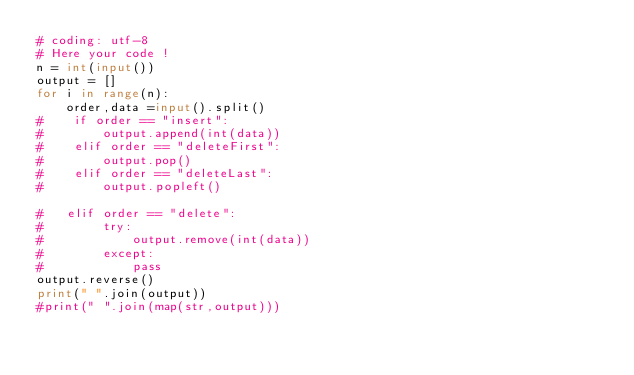<code> <loc_0><loc_0><loc_500><loc_500><_Python_># coding: utf-8
# Here your code !
n = int(input())
output = []
for i in range(n):
    order,data =input().split() 
#    if order == "insert":
#        output.append(int(data))
#    elif order == "deleteFirst":
#        output.pop()
#    elif order == "deleteLast":
#        output.popleft()

#   elif order == "delete":
#        try:
#            output.remove(int(data))
#        except:
#            pass
output.reverse()
print(" ".join(output))
#print(" ".join(map(str,output)))</code> 